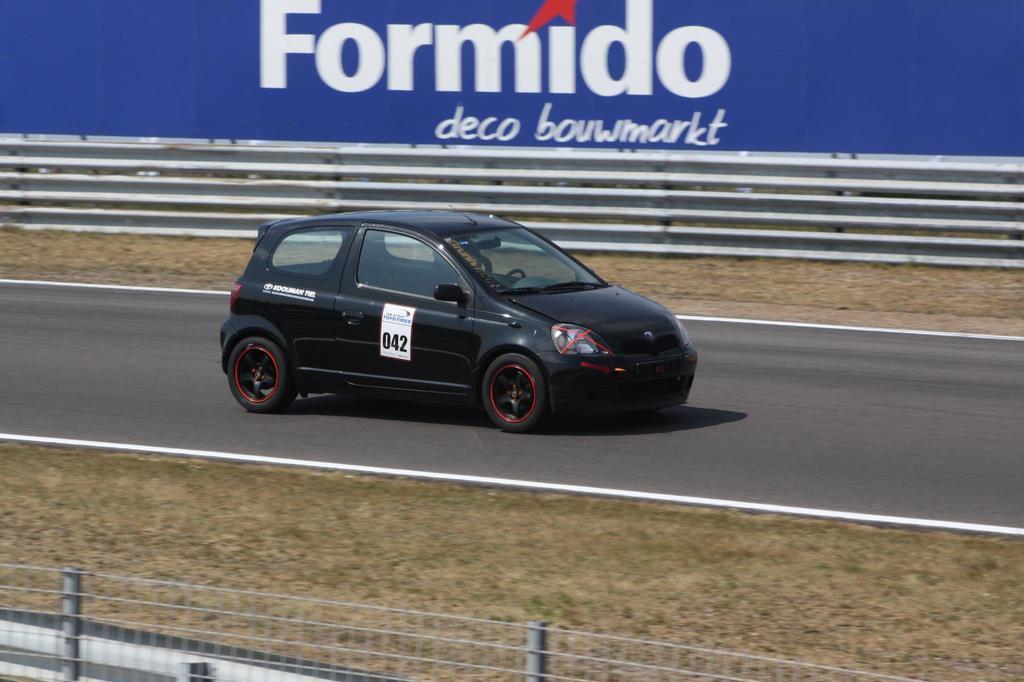Describe this image in one or two sentences. In the center of the image we can see car on the road. At the bottom of the image we can see fencing. In the background we can see an advertisement. 